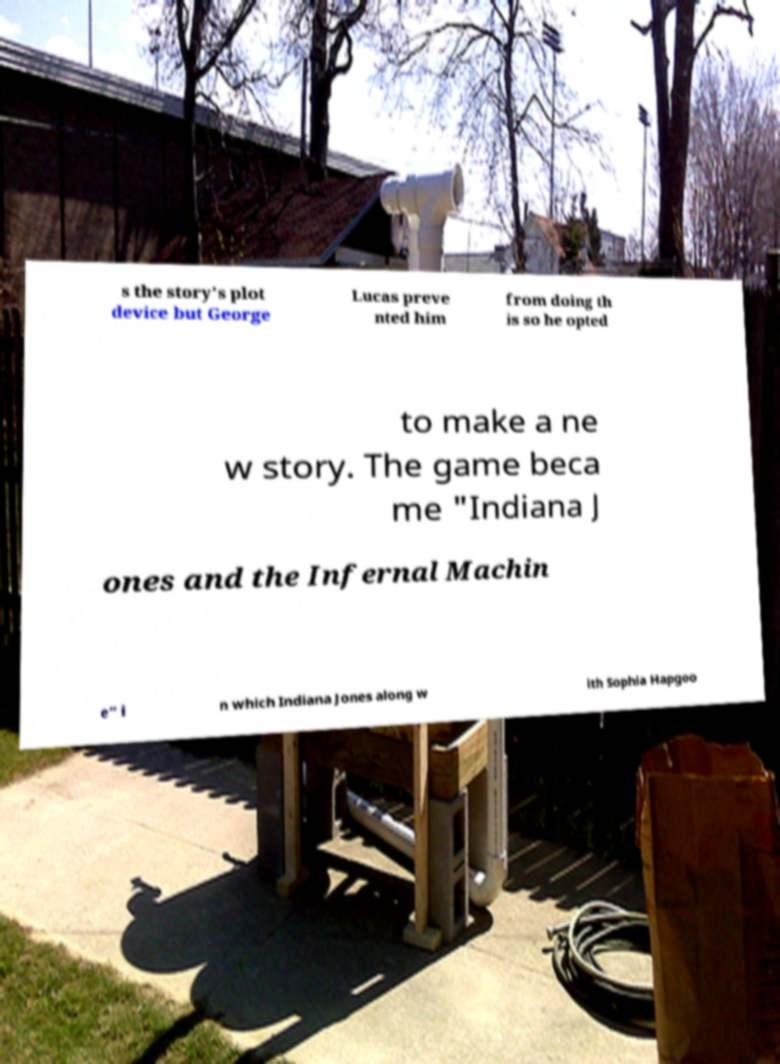Can you read and provide the text displayed in the image?This photo seems to have some interesting text. Can you extract and type it out for me? s the story's plot device but George Lucas preve nted him from doing th is so he opted to make a ne w story. The game beca me "Indiana J ones and the Infernal Machin e" i n which Indiana Jones along w ith Sophia Hapgoo 